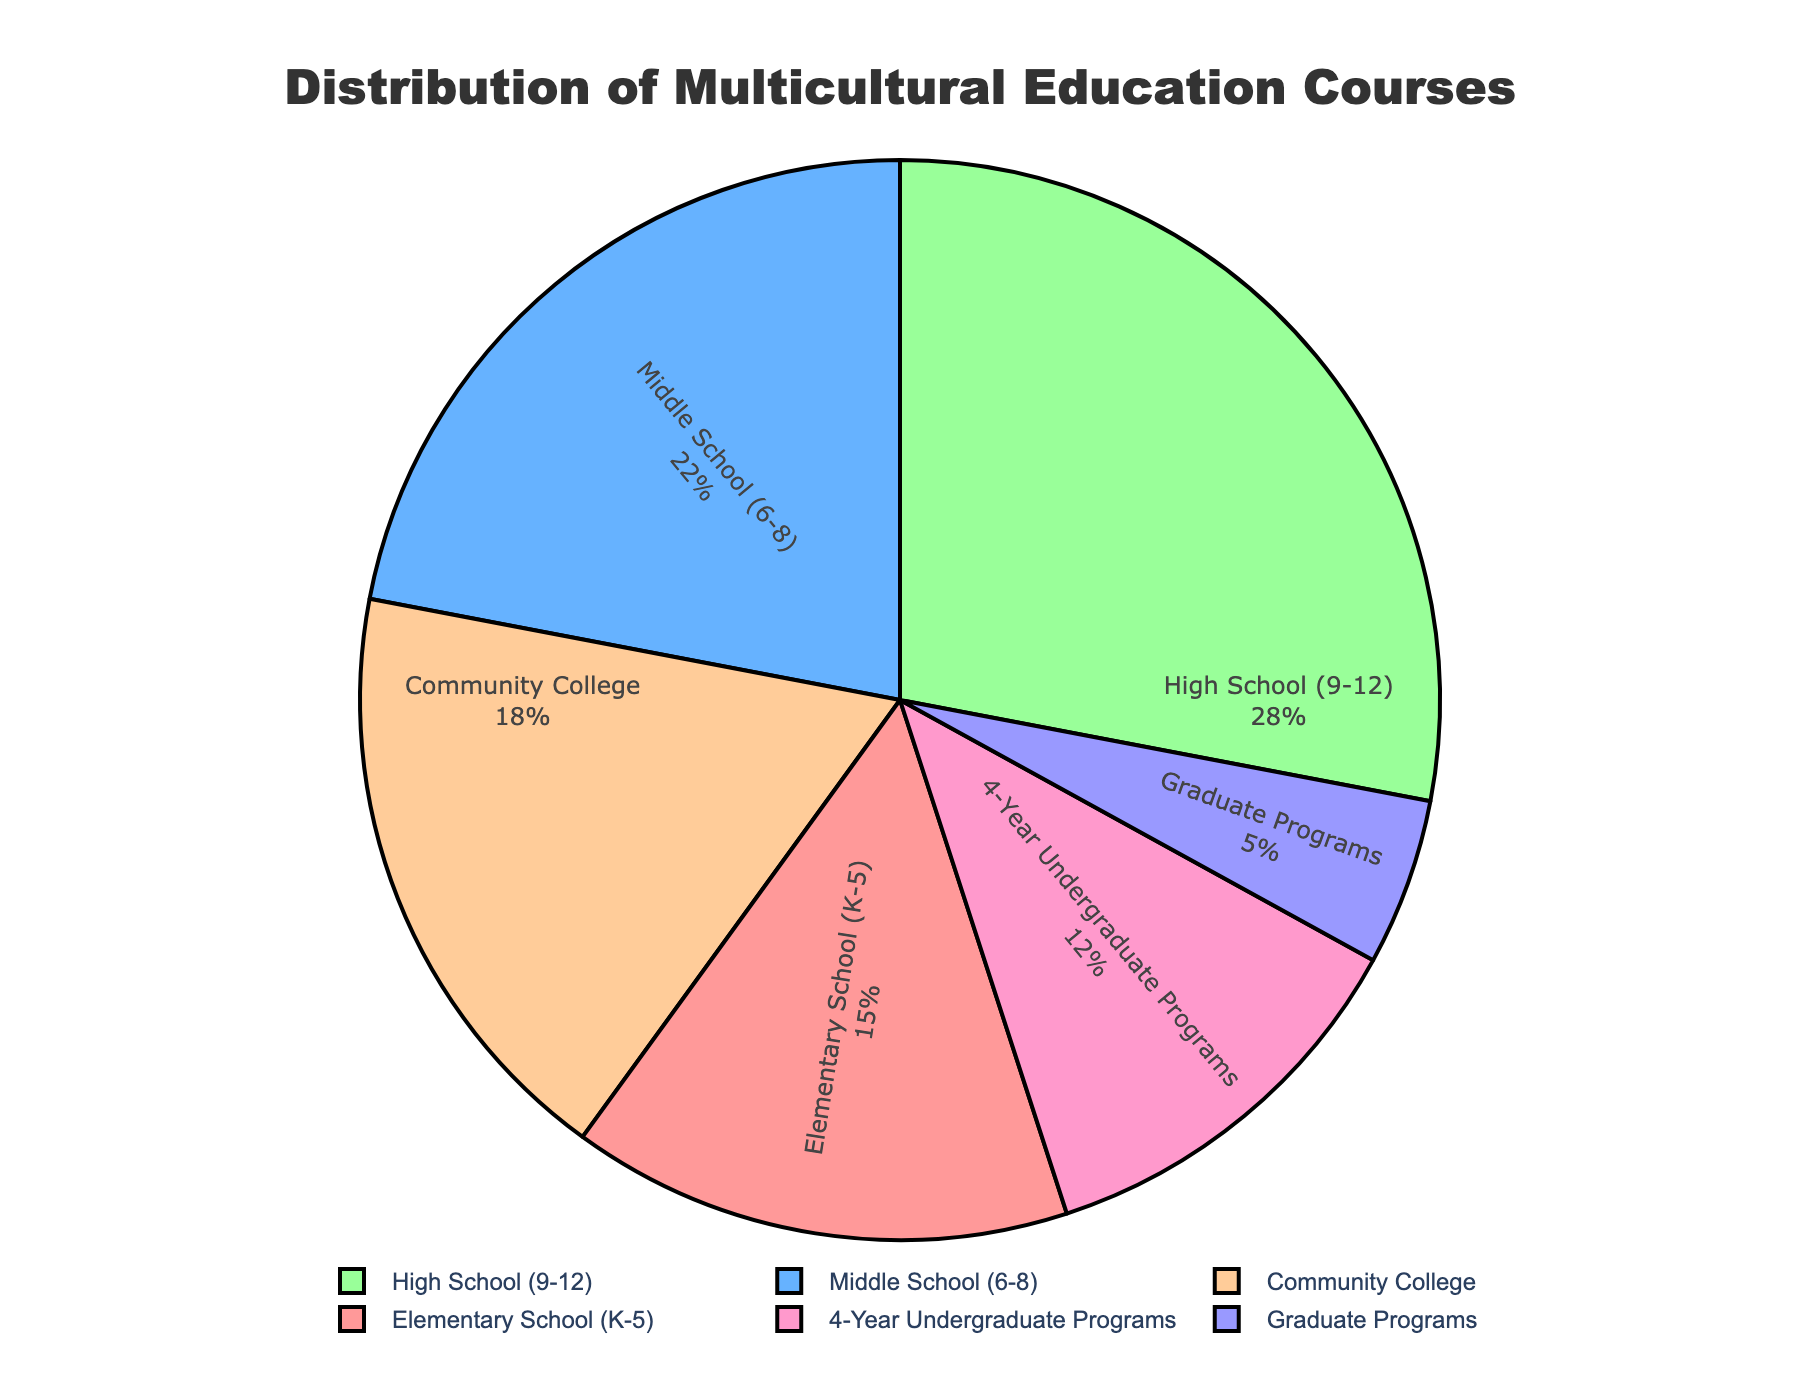What percentage of multicultural education courses are offered at the elementary school level? The percentage is explicitly stated in the pie chart for the Elementary School (K-5) category.
Answer: 15% Which level has the highest percentage of multicultural education courses, and what is that percentage? By comparing all the percentages, the High School (9-12) level has the highest percentage of 28%.
Answer: High School (9-12), 28% How much higher is the percentage of multicultural education courses in high schools compared to graduate programs? The percentage for high schools is 28% and for graduate programs is 5%. The difference is 28% - 5% = 23%.
Answer: 23% Which levels account for more than 20% of the courses? By examining the chart, Middle School (6-8) with 22% and High School (9-12) with 28% are both greater than 20%.
Answer: Middle School (6-8) and High School (9-12) What is the total percentage of multicultural education courses offered from elementary to high school? Add the percentages for Elementary (15%), Middle (22%), and High School (28%): 15% + 22% + 28% = 65%.
Answer: 65% Which level has the smallest representation of multicultural education courses and what is that percentage? Graduate Programs have the smallest percentage at 5%.
Answer: Graduate Programs, 5% How does the percentage of multicultural education courses at community colleges compare to the 4-year undergraduate programs? Community Colleges have 18% and 4-Year Undergraduate Programs have 12%. Community Colleges have 6% more.
Answer: Community Colleges have 6% more If we combine the percentages of community colleges and 4-year undergraduate programs, what is the total? Add the percentages for Community College (18%) and 4-Year Undergraduate Programs (12%): 18% + 12% = 30%.
Answer: 30% What color represents the Middle School (6-8) level in the pie chart? The Middle School (6-8) level segment is assigned the color blue in the pie chart.
Answer: Blue How many levels have a percentage that is greater than or equal to 15%? Elementary (15%), Middle (22%), High School (28%), and Community College (18%) each have percentages greater than or equal to 15%. This is a total of four levels.
Answer: Four 